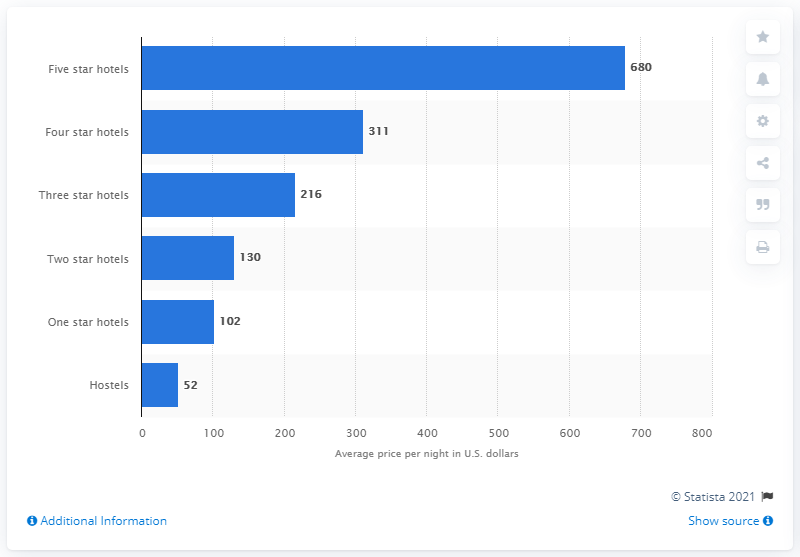Point out several critical features in this image. The average cost per night for a five-star hotel in Miami is approximately 680 USD. 